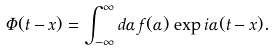<formula> <loc_0><loc_0><loc_500><loc_500>\Phi ( t - x ) = \int _ { - \infty } ^ { \infty } d \alpha \, f ( \alpha ) \, \exp { i \alpha ( t - x ) } .</formula> 